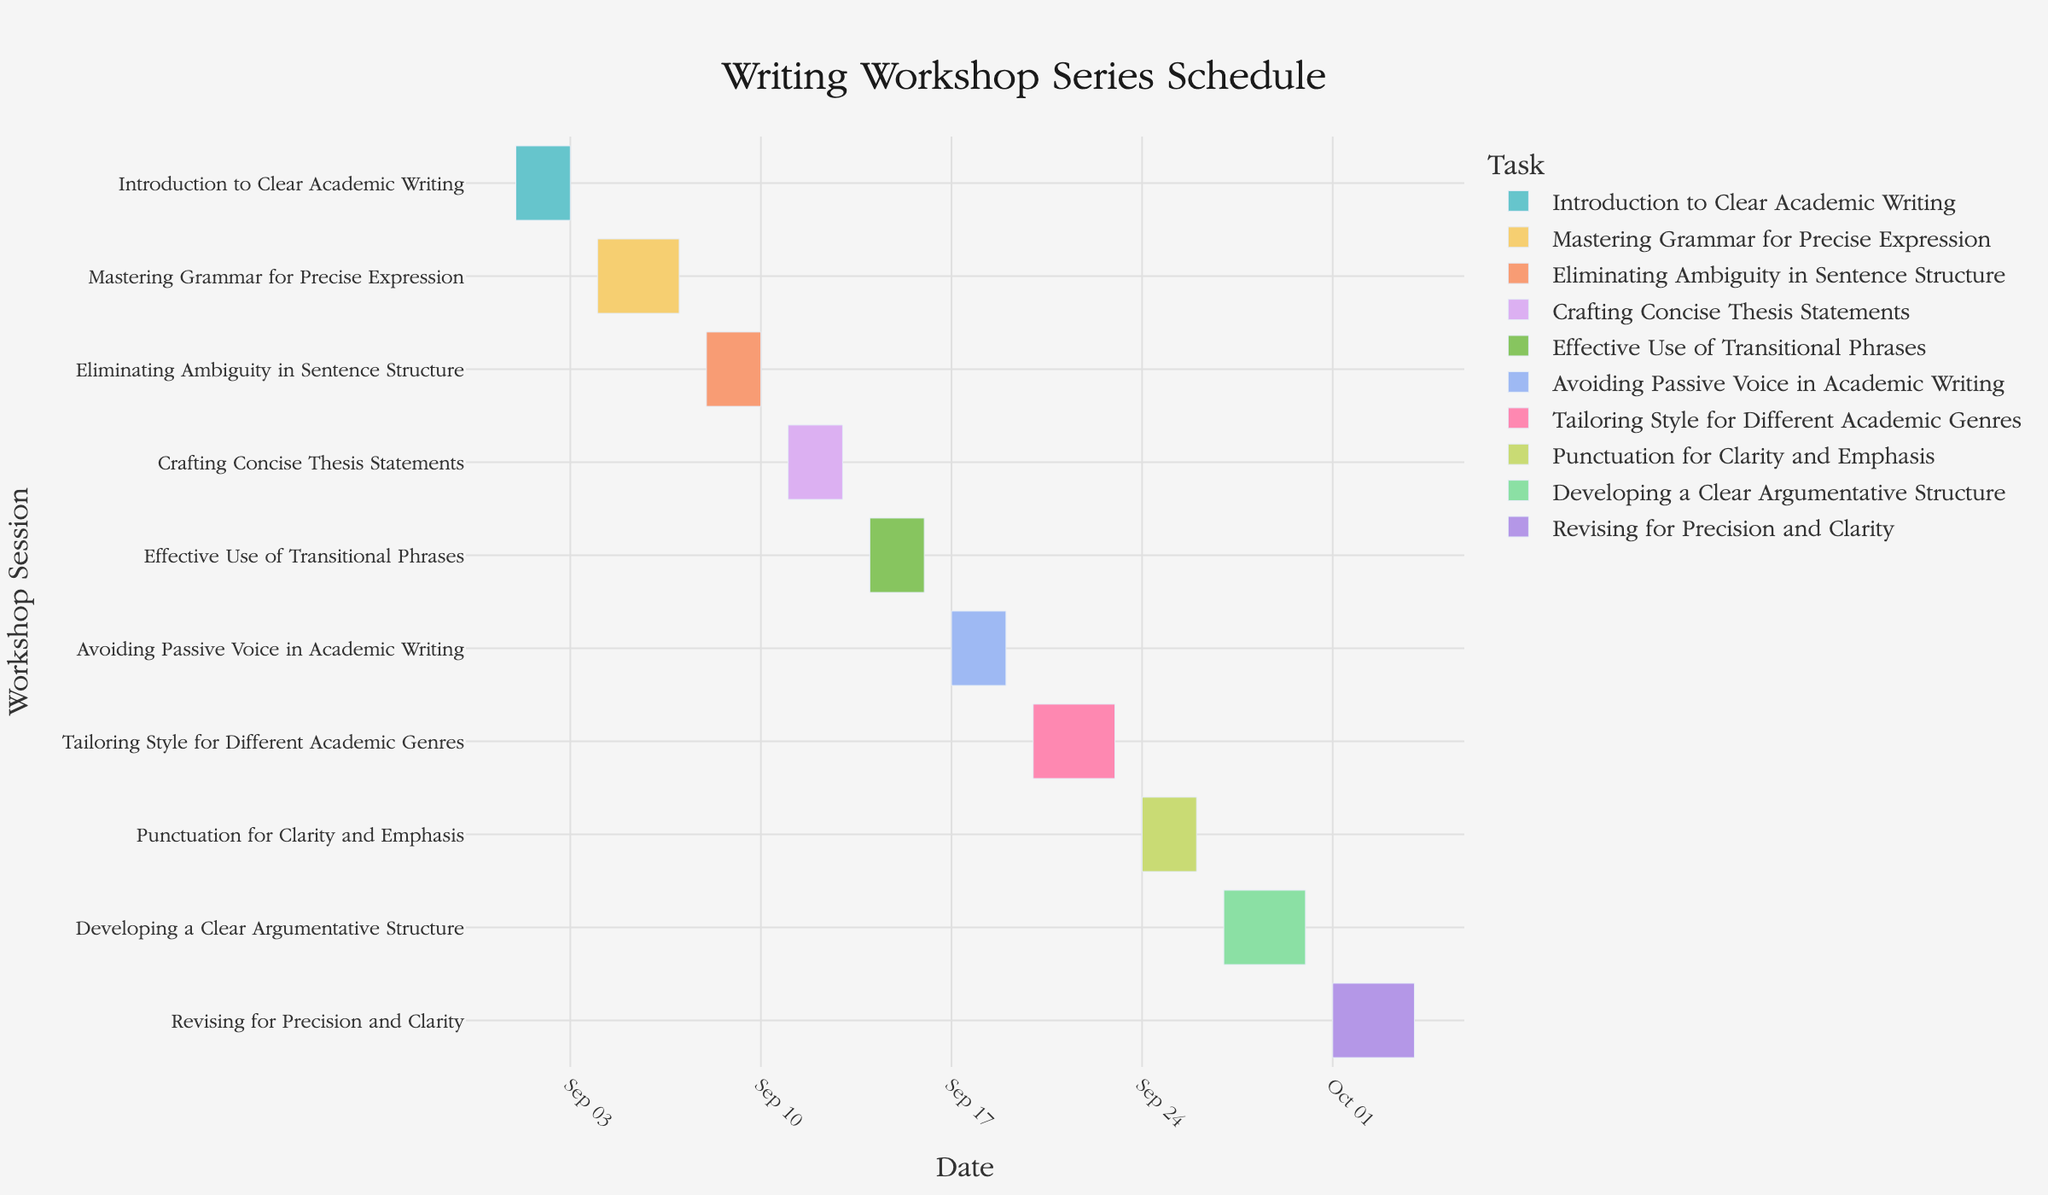What's the title of the Gantt chart? The title is prominently displayed at the top of the chart and reads "Writing Workshop Series Schedule".
Answer: Writing Workshop Series Schedule What is the start date of the first workshop session? By interpreting the first bar on the chart, which represents "Introduction to Clear Academic Writing", you can see that it starts on September 1, 2023.
Answer: September 1, 2023 How many days does the "Mastering Grammar for Precise Expression" workshop last? This workshop runs from September 4 to September 7, inclusive. Counting these dates gives us 4 days.
Answer: 4 days Which workshop, "Crafting Concise Thesis Statements" or "Avoiding Passive Voice in Academic Writing," ends earlier? Referring to the chart, "Crafting Concise Thesis Statements" ends on September 13, while "Avoiding Passive Voice in Academic Writing" ends on September 19. Therefore, "Crafting Concise Thesis Statements" finishes earlier.
Answer: Crafting Concise Thesis Statements On what date does the "Eliminating Ambiguity in Sentence Structure" workshop end? This session is represented by a bar that ends on September 10, 2023, as indicated in the chart.
Answer: September 10, 2023 What is the total duration (in days) of the "Effective Use of Transitional Phrases" workshop? The workshop starts on September 14 and ends on September 16. The total duration inclusive of these dates is 3 days.
Answer: 3 days Which workshop has the longest duration in the entire series? Examining the lengths of the bars, "Tailoring Style for Different Academic Genres" has the longest duration, running from September 20 to September 23.
Answer: Tailoring Style for Different Academic Genres How many workshops run for 3 days? From the chart, "Introduction to Clear Academic Writing", "Eliminating Ambiguity in Sentence Structure", "Crafting Concise Thesis Statements", and "Effective Use of Transitional Phrases" each run for 3 days. Thus, there are 4 such workshops.
Answer: 4 workshops Which workshop starts immediately after "Punctuation for Clarity and Emphasis"? By following the sequence on the chart, "Developing a Clear Argumentative Structure" starts immediately after.
Answer: Developing a Clear Argumentative Structure What is the difference in days between the start of "Revising for Precision and Clarity" and the end of "Mastering Grammar for Precise Expression"? "Revising for Precision and Clarity" starts on October 1, 2023, and "Mastering Grammar for Precise Expression" ends on September 7, 2023. The difference is 24 days.
Answer: 24 days 